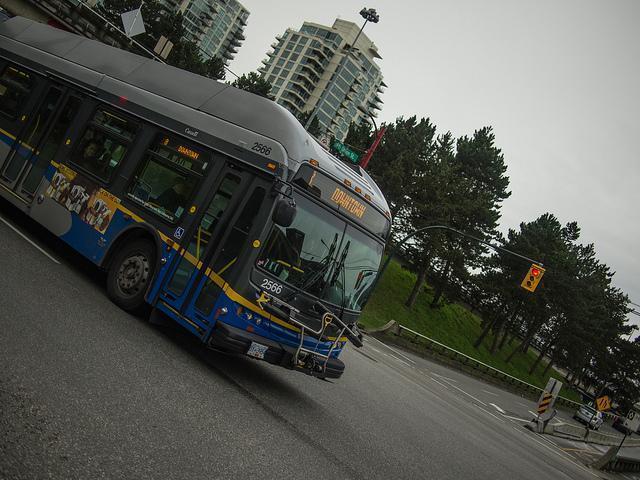How many buses?
Give a very brief answer. 1. 